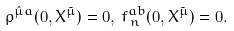<formula> <loc_0><loc_0><loc_500><loc_500>\rho ^ { { \hat { \mu } } a } ( 0 , X ^ { \tilde { \mu } } ) = 0 , \, f ^ { a b } _ { \, n } ( 0 , X ^ { \tilde { \mu } } ) = 0 .</formula> 